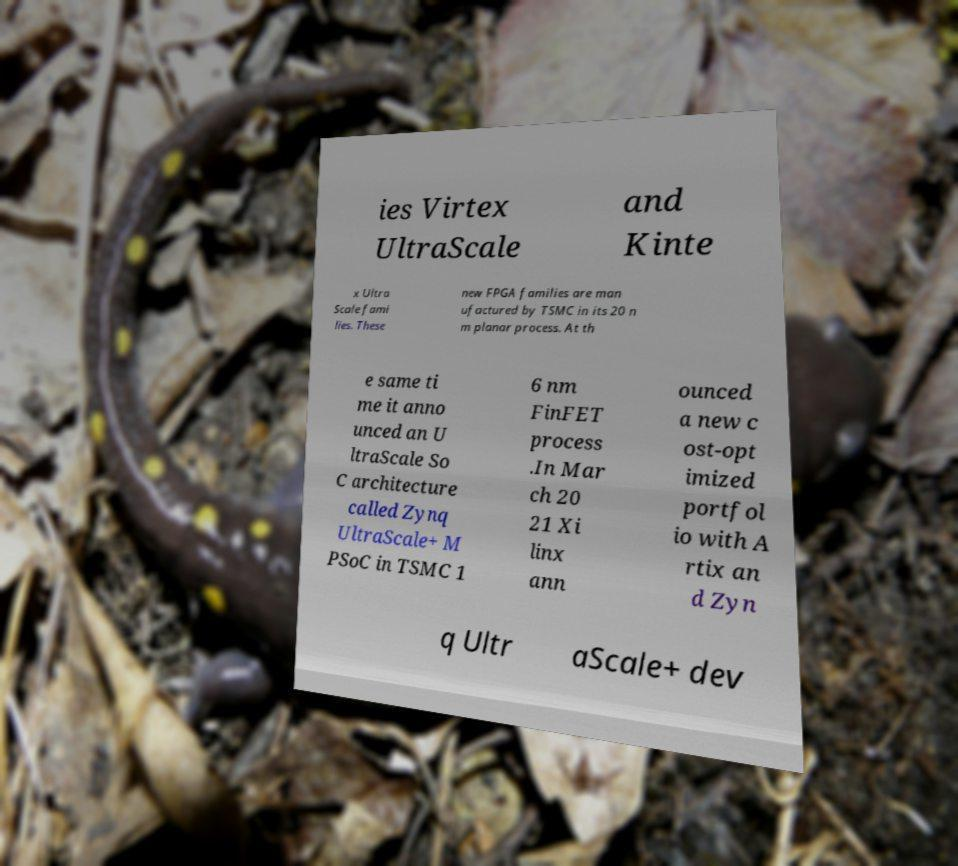Please read and relay the text visible in this image. What does it say? ies Virtex UltraScale and Kinte x Ultra Scale fami lies. These new FPGA families are man ufactured by TSMC in its 20 n m planar process. At th e same ti me it anno unced an U ltraScale So C architecture called Zynq UltraScale+ M PSoC in TSMC 1 6 nm FinFET process .In Mar ch 20 21 Xi linx ann ounced a new c ost-opt imized portfol io with A rtix an d Zyn q Ultr aScale+ dev 